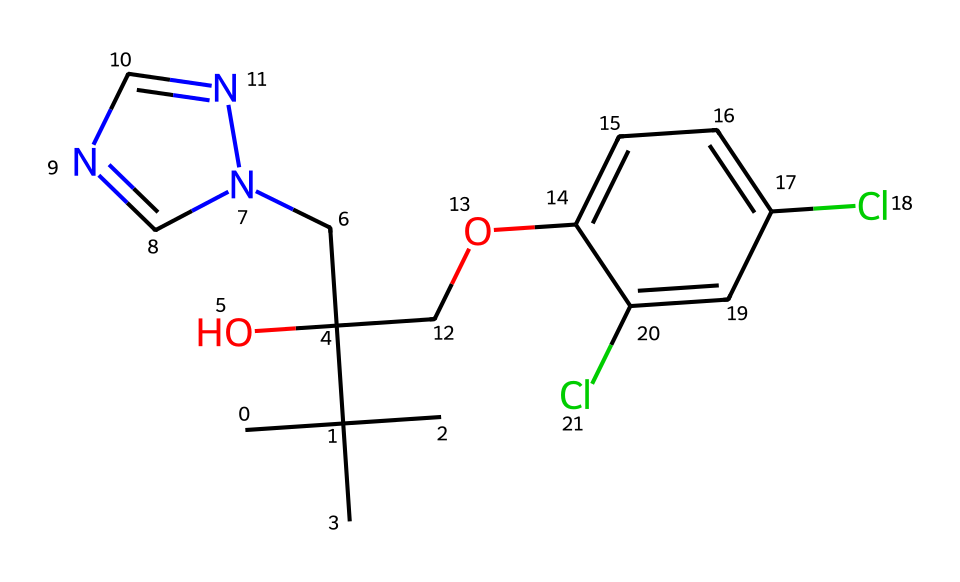What is the molecular formula of propiconazole? To determine the molecular formula, you identify the types and counts of atoms in the SMILES representation. Counting each atom: Carbon (C) = 14, Hydrogen (H) = 18, Nitrogen (N) = 4, and Oxygen (O) = 2 gives C14H18Cl2N4O2.
Answer: C14H18Cl2N4O2 How many chlorine atoms are present in this structure? Scanning the SMILES representation reveals the presence of the 'Cl' symbol twice, indicating two chlorine atoms.
Answer: 2 What type of functional group is featured prominently in propiconazole? The presence of the 'N' in 'Cn1cncn1' indicates that propiconazole contains a triazole ring, which is a five-membered ring with three nitrogen atoms, a specific hallmark of triazole fungicides.
Answer: triazole What is the primary role of propiconazole in agriculture? Propiconazole is primarily used as a fungicide to protect plants from fungal infections and diseases. This is typical for triazole compounds known for their antifungal properties.
Answer: fungicide What is the significance of the branched alkyl group in this chemical? The branched alkyl group (CC(C)(C)) enhances lipophilicity, which can improve the absorption and efficacy of the fungicide in agricultural applications. This structure allows for better interaction with fungal cell membranes.
Answer: lipophilicity How many nitrogen atoms are in the triazole ring of propiconazole? The triazole ring is characterized by three nitrogen atoms as indicated by the 'n' and 'N' in the 'Cn1cncn1' part of the SMILES. Counting these confirms the presence of three nitrogen atoms.
Answer: 3 